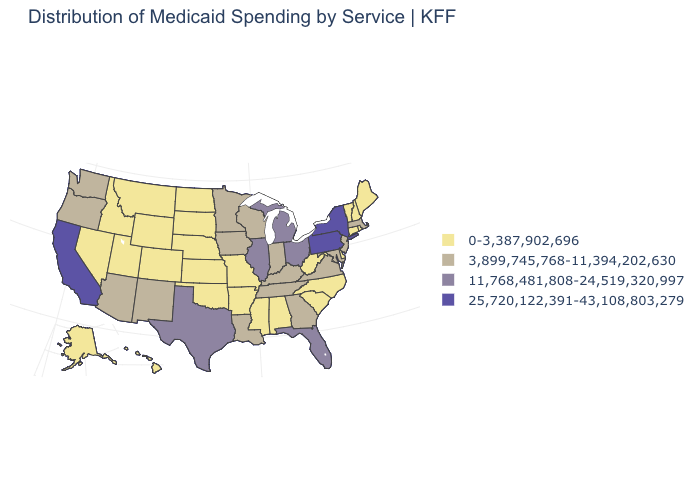What is the value of South Dakota?
Write a very short answer. 0-3,387,902,696. Among the states that border Massachusetts , which have the highest value?
Write a very short answer. New York. Does the map have missing data?
Short answer required. No. What is the value of Minnesota?
Quick response, please. 3,899,745,768-11,394,202,630. Which states have the lowest value in the USA?
Keep it brief. Alabama, Alaska, Arkansas, Colorado, Connecticut, Delaware, Hawaii, Idaho, Kansas, Maine, Mississippi, Missouri, Montana, Nebraska, Nevada, New Hampshire, North Carolina, North Dakota, Oklahoma, Rhode Island, South Carolina, South Dakota, Utah, Vermont, West Virginia, Wyoming. What is the value of Arkansas?
Concise answer only. 0-3,387,902,696. Name the states that have a value in the range 25,720,122,391-43,108,803,279?
Be succinct. California, New York, Pennsylvania. Does South Dakota have a lower value than Mississippi?
Write a very short answer. No. What is the value of Colorado?
Quick response, please. 0-3,387,902,696. Among the states that border Utah , which have the lowest value?
Concise answer only. Colorado, Idaho, Nevada, Wyoming. How many symbols are there in the legend?
Answer briefly. 4. Name the states that have a value in the range 3,899,745,768-11,394,202,630?
Concise answer only. Arizona, Georgia, Indiana, Iowa, Kentucky, Louisiana, Maryland, Massachusetts, Minnesota, New Jersey, New Mexico, Oregon, Tennessee, Virginia, Washington, Wisconsin. How many symbols are there in the legend?
Give a very brief answer. 4. Among the states that border Maryland , which have the highest value?
Answer briefly. Pennsylvania. Does Washington have the lowest value in the West?
Be succinct. No. 